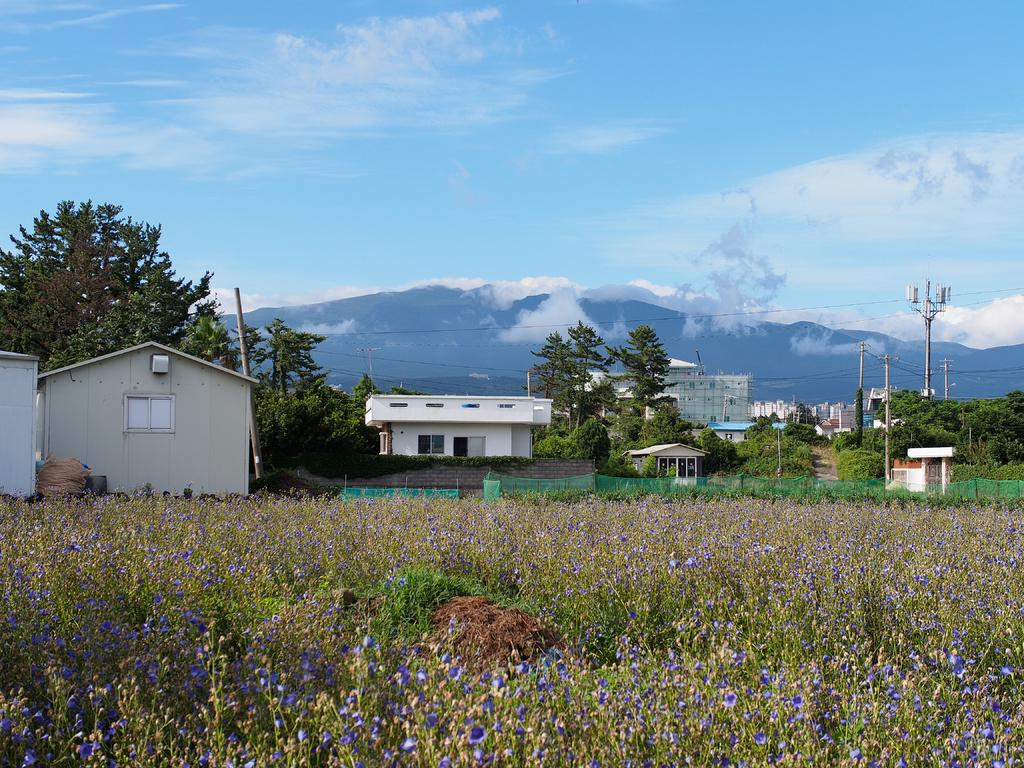What type of structures can be seen in the image? There are many buildings in the image. What natural elements are present in the image? There are trees, a mountain, and grass visible in the image. What man-made objects can be seen in the image? There is an electric pole and electric wires in the image. What type of plant is visible in the image? There is a plant in the image. What type of tin can be seen in the image? There is no tin present in the image. Is there any indication of war in the image? There is no indication of war in the image; it features buildings, trees, a mountain, and other peaceful elements. 